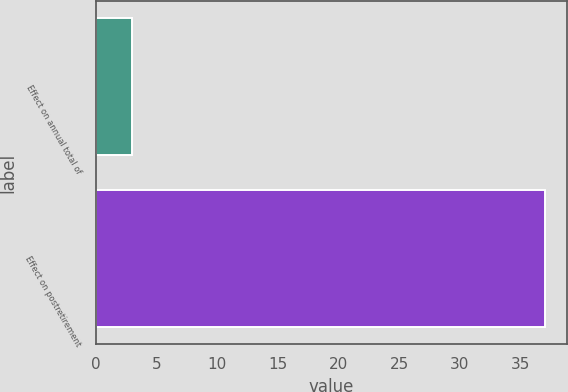Convert chart to OTSL. <chart><loc_0><loc_0><loc_500><loc_500><bar_chart><fcel>Effect on annual total of<fcel>Effect on postretirement<nl><fcel>3<fcel>37<nl></chart> 